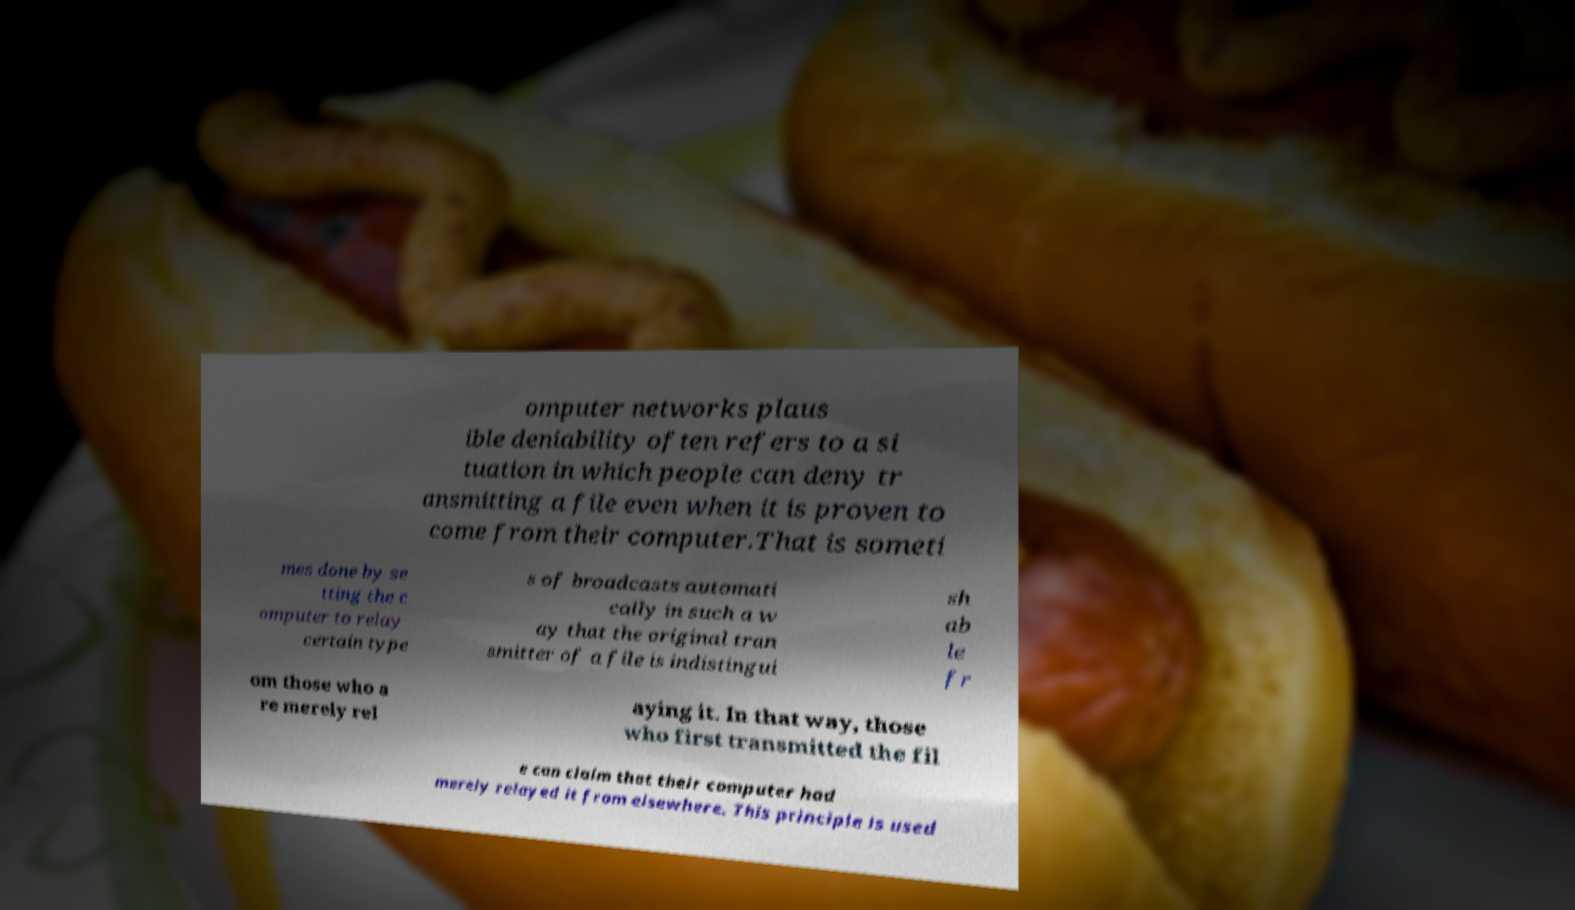For documentation purposes, I need the text within this image transcribed. Could you provide that? omputer networks plaus ible deniability often refers to a si tuation in which people can deny tr ansmitting a file even when it is proven to come from their computer.That is someti mes done by se tting the c omputer to relay certain type s of broadcasts automati cally in such a w ay that the original tran smitter of a file is indistingui sh ab le fr om those who a re merely rel aying it. In that way, those who first transmitted the fil e can claim that their computer had merely relayed it from elsewhere. This principle is used 